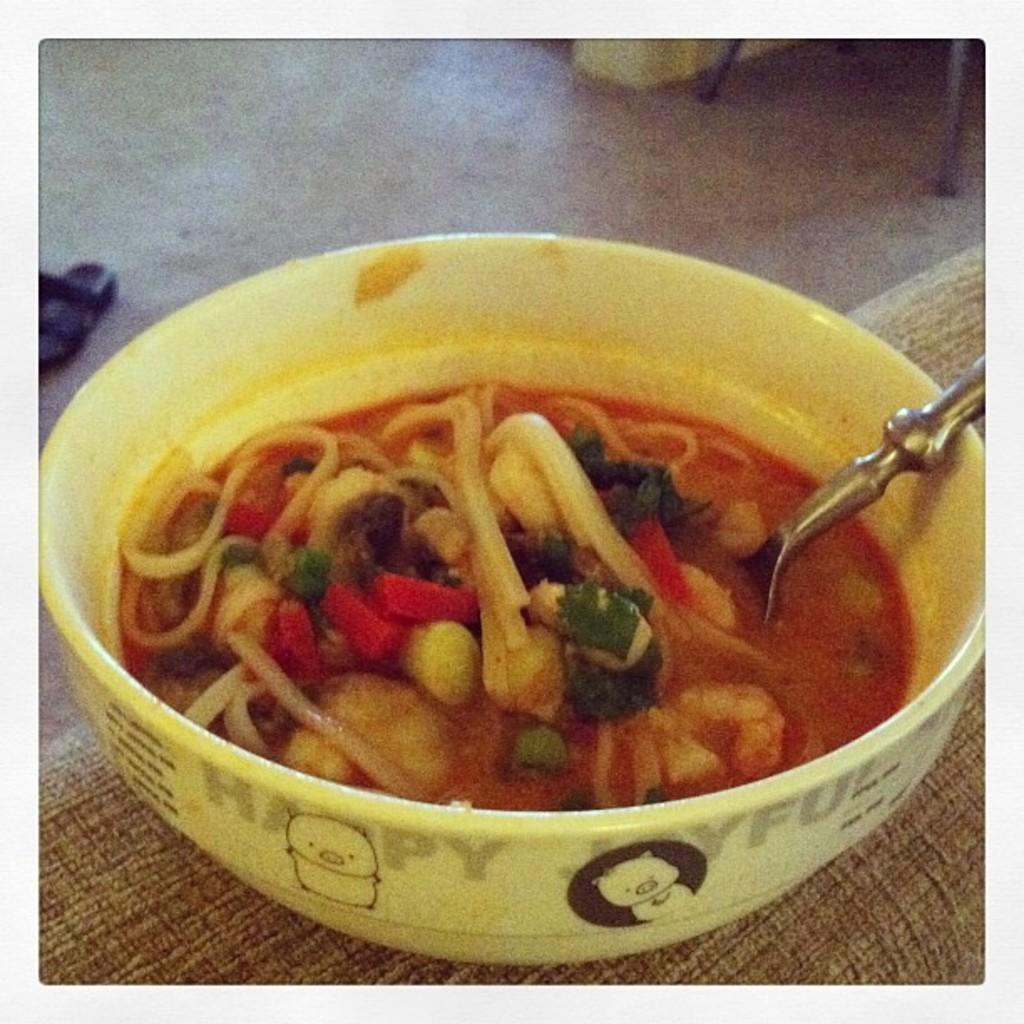Can you describe this image briefly? In this image I can see the bowl with food. I can see the food is colorful and I can see the spoon in the bowl. It is on the brown color surface. To the side I can see the footwear. 